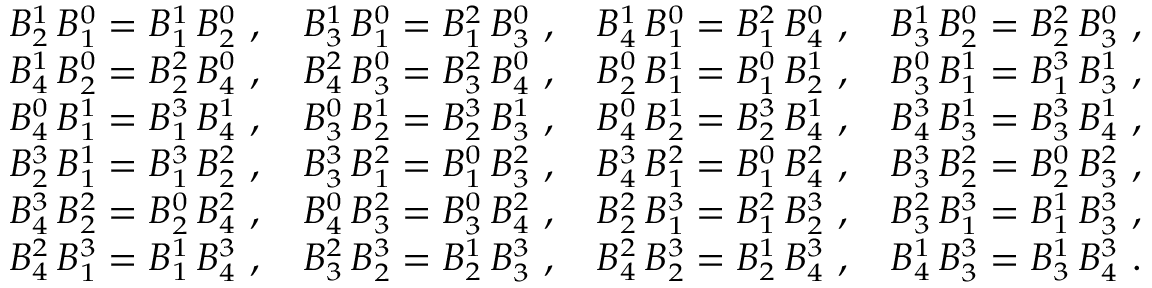<formula> <loc_0><loc_0><loc_500><loc_500>{ \begin{array} { l l l l } { B _ { 2 } ^ { 1 } \, B _ { 1 } ^ { 0 } = B _ { 1 } ^ { 1 } \, B _ { 2 } ^ { 0 } \ , } & { B _ { 3 } ^ { 1 } \, B _ { 1 } ^ { 0 } = B _ { 1 } ^ { 2 } \, B _ { 3 } ^ { 0 } \ , } & { B _ { 4 } ^ { 1 } \, B _ { 1 } ^ { 0 } = B _ { 1 } ^ { 2 } \, B _ { 4 } ^ { 0 } \ , } & { B _ { 3 } ^ { 1 } \, B _ { 2 } ^ { 0 } = B _ { 2 } ^ { 2 } \, B _ { 3 } ^ { 0 } \ , } \\ { B _ { 4 } ^ { 1 } \, B _ { 2 } ^ { 0 } = B _ { 2 } ^ { 2 } \, B _ { 4 } ^ { 0 } \ , } & { B _ { 4 } ^ { 2 } \, B _ { 3 } ^ { 0 } = B _ { 3 } ^ { 2 } \, B _ { 4 } ^ { 0 } \ , } & { B _ { 2 } ^ { 0 } \, B _ { 1 } ^ { 1 } = B _ { 1 } ^ { 0 } \, B _ { 2 } ^ { 1 } \ , } & { B _ { 3 } ^ { 0 } \, B _ { 1 } ^ { 1 } = B _ { 1 } ^ { 3 } \, B _ { 3 } ^ { 1 } \ , } \\ { B _ { 4 } ^ { 0 } \, B _ { 1 } ^ { 1 } = B _ { 1 } ^ { 3 } \, B _ { 4 } ^ { 1 } \ , } & { B _ { 3 } ^ { 0 } \, B _ { 2 } ^ { 1 } = B _ { 2 } ^ { 3 } \, B _ { 3 } ^ { 1 } \ , } & { B _ { 4 } ^ { 0 } \, B _ { 2 } ^ { 1 } = B _ { 2 } ^ { 3 } \, B _ { 4 } ^ { 1 } \ , } & { B _ { 4 } ^ { 3 } \, B _ { 3 } ^ { 1 } = B _ { 3 } ^ { 3 } \, B _ { 4 } ^ { 1 } \ , } \\ { B _ { 2 } ^ { 3 } \, B _ { 1 } ^ { 1 } = B _ { 1 } ^ { 3 } \, B _ { 2 } ^ { 2 } \ , } & { B _ { 3 } ^ { 3 } \, B _ { 1 } ^ { 2 } = B _ { 1 } ^ { 0 } \, B _ { 3 } ^ { 2 } \ , } & { B _ { 4 } ^ { 3 } \, B _ { 1 } ^ { 2 } = B _ { 1 } ^ { 0 } \, B _ { 4 } ^ { 2 } \ , } & { B _ { 3 } ^ { 3 } \, B _ { 2 } ^ { 2 } = B _ { 2 } ^ { 0 } \, B _ { 3 } ^ { 2 } \ , } \\ { B _ { 4 } ^ { 3 } \, B _ { 2 } ^ { 2 } = B _ { 2 } ^ { 0 } \, B _ { 4 } ^ { 2 } \ , } & { B _ { 4 } ^ { 0 } \, B _ { 3 } ^ { 2 } = B _ { 3 } ^ { 0 } \, B _ { 4 } ^ { 2 } \ , } & { B _ { 2 } ^ { 2 } \, B _ { 1 } ^ { 3 } = B _ { 1 } ^ { 2 } \, B _ { 2 } ^ { 3 } \ , } & { B _ { 3 } ^ { 2 } \, B _ { 1 } ^ { 3 } = B _ { 1 } ^ { 1 } \, B _ { 3 } ^ { 3 } \ , } \\ { B _ { 4 } ^ { 2 } \, B _ { 1 } ^ { 3 } = B _ { 1 } ^ { 1 } \, B _ { 4 } ^ { 3 } \ , } & { B _ { 3 } ^ { 2 } \, B _ { 2 } ^ { 3 } = B _ { 2 } ^ { 1 } \, B _ { 3 } ^ { 3 } \ , } & { B _ { 4 } ^ { 2 } \, B _ { 2 } ^ { 3 } = B _ { 2 } ^ { 1 } \, B _ { 4 } ^ { 3 } \ , } & { B _ { 4 } ^ { 1 } \, B _ { 3 } ^ { 3 } = B _ { 3 } ^ { 1 } \, B _ { 4 } ^ { 3 } \ . } \end{array} }</formula> 